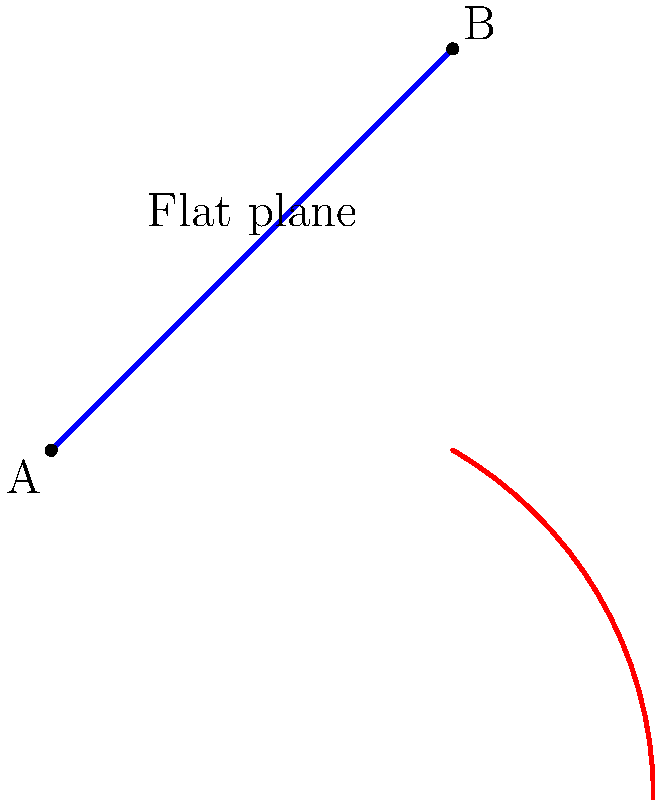As a travel agent helping international students plan their journeys, you often need to consider different routes. In the diagram above, two paths are shown between points A and B: a straight line on a flat plane (blue) and a curved path on a spherical surface (red). Which path represents the shortest distance between A and B, and why is this concept important when planning long-distance flights for students? To answer this question, let's break it down step-by-step:

1. Flat plane (blue line):
   - This represents the shortest path between two points on a flat surface.
   - It follows the principle of Euclidean geometry, where the shortest distance between two points is a straight line.
   - Length = $\sqrt{(x_2-x_1)^2 + (y_2-y_1)^2}$

2. Curved surface (red arc):
   - This represents the shortest path between two points on a curved surface (like the Earth's surface).
   - It follows the principles of non-Euclidean geometry, specifically spherical geometry.
   - The shortest path on a sphere is called a "great circle" route.

3. Comparison:
   - While the straight line appears shorter in the 2D representation, it's not actually the shortest path when considering the Earth's curvature.
   - The curved path (red arc) represents the true shortest distance between A and B on a spherical surface.

4. Importance in long-distance flight planning:
   - Earth is (approximately) a sphere, so long-distance flights follow great circle routes.
   - These routes minimize fuel consumption and travel time.
   - Understanding this concept helps in accurately estimating flight durations and costs for students.

5. Application in travel planning:
   - When booking long-haul flights for students, the actual flight path will be closer to the curved line than the straight line on a flat map.
   - This affects flight times, which is crucial for students with connecting flights or tight schedules.
   - It also impacts the countries/regions the flight may pass over, which could affect visa requirements for certain routes.

In conclusion, the curved path (red arc) represents the shortest distance between A and B on a spherical surface, which is more relevant for long-distance travel planning on Earth.
Answer: The curved path (red arc) is shorter. This concept is important for accurately estimating flight durations, costs, and potential stopovers when planning long-distance travel for students. 